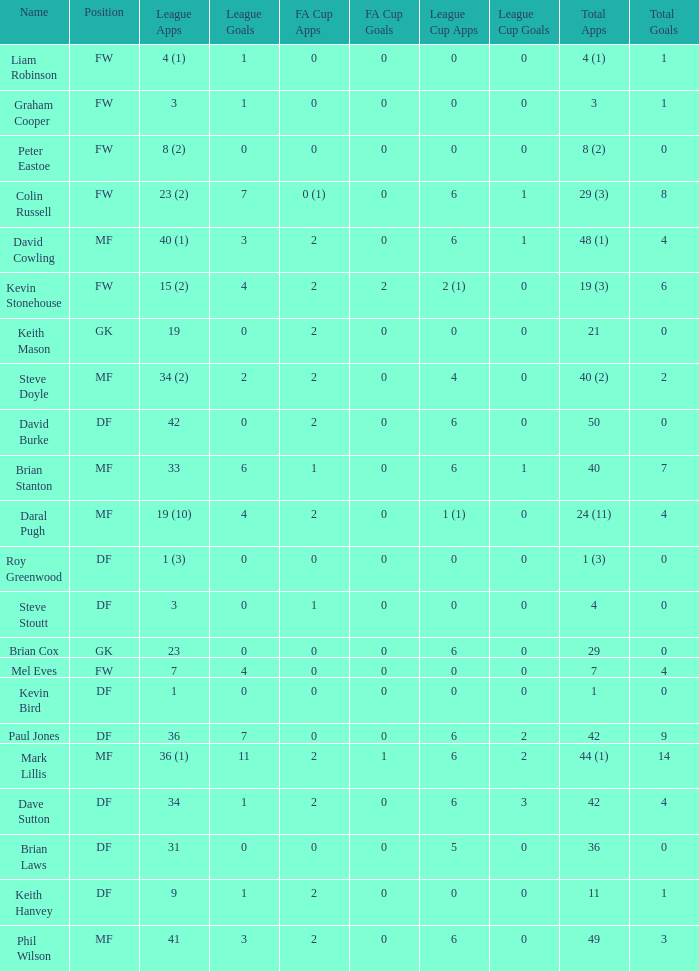What is the most total goals for a player having 0 FA Cup goals and 41 League appearances? 3.0. 